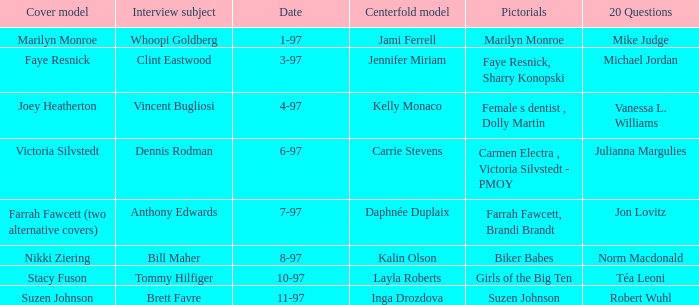Who was the centerfold model when a pictorial was done on marilyn monroe? Jami Ferrell. 